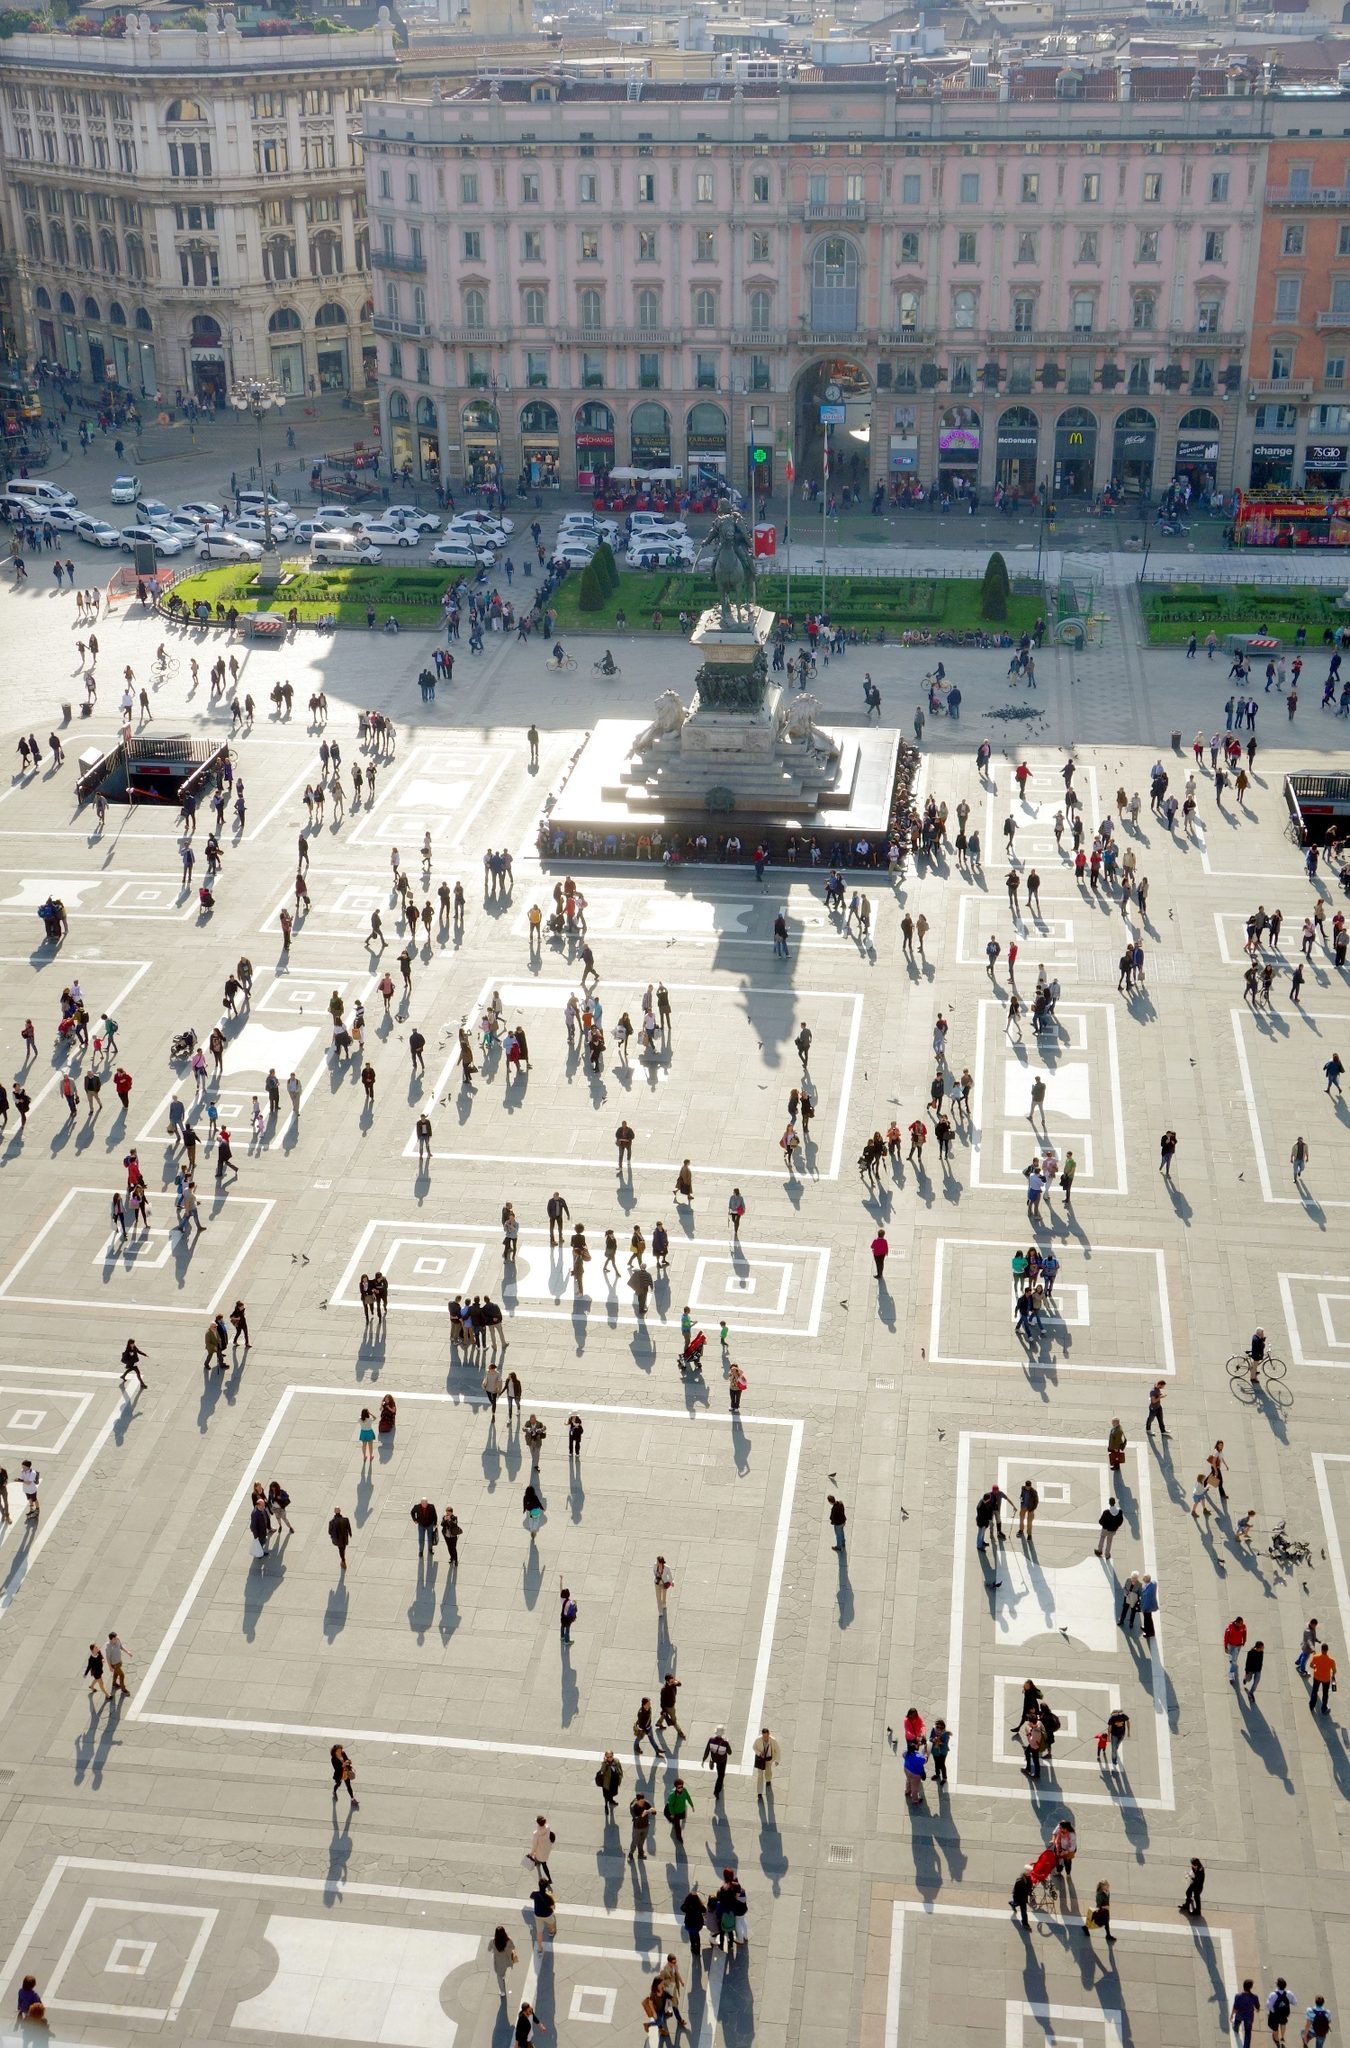Imagine an alternate universe where the Piazza del Duomo is a portal to different worlds. How would this change the dynamics in Milan? In an alternate universe where the Piazza del Duomo serves as a portal to different worlds, Milan would become a focal point of interdimensional tourism and trade. The square would be filled with travelers not just from different parts of Earth but from entirely different realms and civilizations. Bizarre and wonderful creatures would mix with humans, bringing exotic goods, knowledge, and technology. The architectural marvels of the square might be complemented by alien structures or floating kiosks. Cultural diversity would reach unimaginable heights, and security would be enhanced to manage the influx of visitors from different worlds. It would be a bustling hub of interdimensional exchange, promoting unprecedented levels of cultural and technological fusion. 